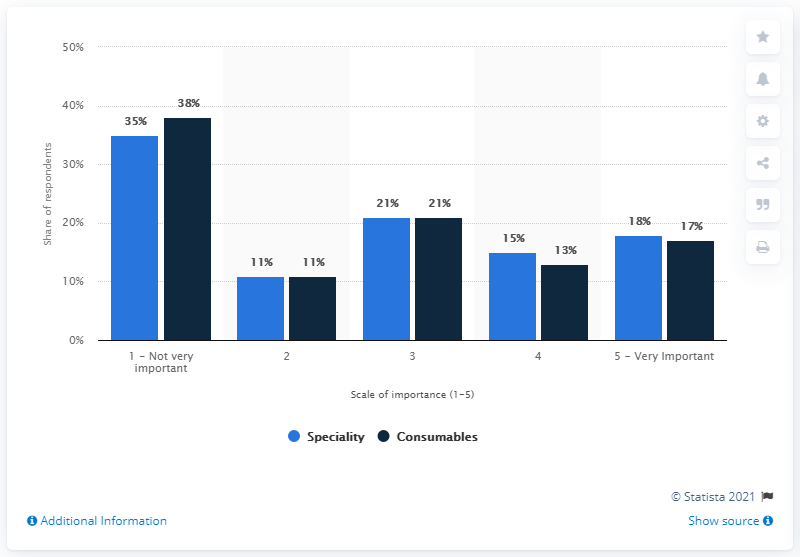Give some essential details in this illustration. The ratio between Very Important and Not Very Important in Speciality (blue bar) is 0.514285714... The missing data (in percentage) can be found by looking for the numbers 35, 38, 11, 11, 21, 21, 15, 13, 17, and 18. 